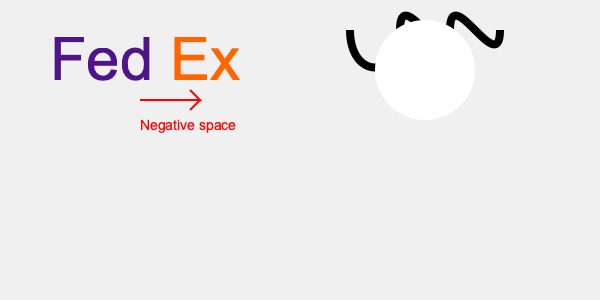В логотипах FedEx и WWF (World Wildlife Fund) используется техника негативного пространства. Какой элемент скрыт в негативном пространстве логотипа FedEx, и как эта техника усиливает общий дизайн и посыл бренда? 1. Негативное пространство в дизайне логотипов - это намеренное использование пустого пространства для создания дополнительных элементов или форм.

2. В логотипе FedEx негативное пространство используется между буквами 'E' и 'x':
   - Между этими буквами формируется стрелка, направленная вправо.
   - Эта стрелка символизирует скорость, точность и движение вперед.

3. Значение для бренда FedEx:
   - Стрелка подчеркивает идею быстрой и точной доставки.
   - Она добавляет динамику и современность логотипу.
   - Скрытый элемент создает момент "aha" для зрителя, делая логотип запоминающимся.

4. В логотипе WWF также используется негативное пространство:
   - Белое пространство между черными линиями формирует силуэт панды.
   - Это эффективно передает миссию организации по защите дикой природы.

5. Преимущества использования негативного пространства:
   - Создает визуальный интерес и глубину в дизайне.
   - Делает логотип более запоминающимся и уникальным.
   - Позволяет передать несколько идей в одном простом дизайне.

6. Для стартапа использование подобных техник может помочь создать запоминающийся и многозначный логотип, который будет эффективно представлять бренд и его ценности.
Answer: Стрелка, символизирующая скорость и точность доставки. 